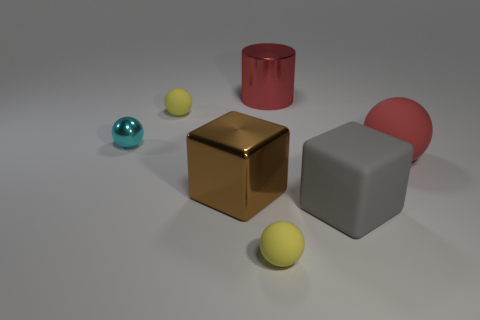Add 1 large green matte objects. How many objects exist? 8 Subtract all spheres. How many objects are left? 3 Subtract all small yellow matte blocks. Subtract all gray rubber cubes. How many objects are left? 6 Add 2 big gray matte things. How many big gray matte things are left? 3 Add 2 big cyan metal spheres. How many big cyan metal spheres exist? 2 Subtract 0 blue cubes. How many objects are left? 7 